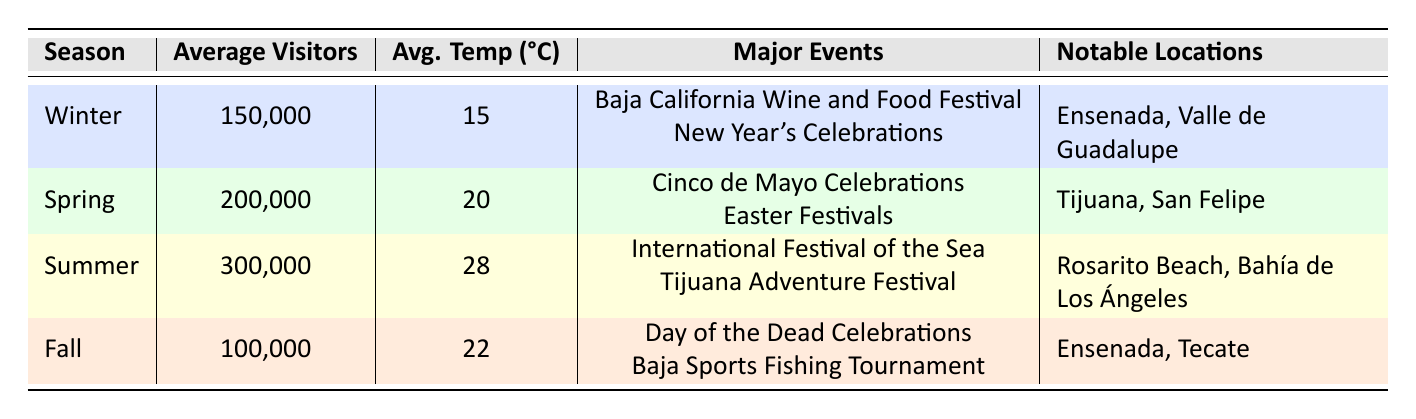What is the average number of visitors during the summer season? From the table, the summer season has 300,000 average visitors listed under the "Average Visitors" column.
Answer: 300,000 Which season has the highest average temperature? By examining the average temperature values in the table, summer has the highest average temperature at 28 degrees Celsius.
Answer: Summer How many major events are celebrated in spring? The spring season lists two major events: "Cinco de Mayo Celebrations" and "Easter Festivals," as shown in the table under the "Major Events" column.
Answer: 2 What is the total number of average visitors across all seasons? To find the total number of average visitors, we need to sum the average visitors from each season: 150,000 (Winter) + 200,000 (Spring) + 300,000 (Summer) + 100,000 (Fall) = 750,000 visitors.
Answer: 750,000 Is Ensenada a notable location in the fall season? The table indicates that Ensenada is listed under the "Notable Locations" for the fall season, confirming that it is indeed a notable location for this season.
Answer: Yes Which season has the least number of average visitors and what is the number? By comparing the average visitors among all seasons, fall has the least number of average visitors at 100,000, as evidenced in the table.
Answer: Fall, 100,000 During which season do visitors experience the highest average temperature and how much is it? The summer season provides the highest average temperature at 28 degrees Celsius, according to the "Avg. Temp" column in the table.
Answer: Summer, 28 degrees Celsius Is there any major event occurring in winter related to food and wine? Yes, the table mentions the "Baja California Wine and Food Festival" as a major event in the winter season, confirming that there is a relevant event.
Answer: Yes What is the difference in average visitors between summer and fall? The average visitors in summer is 300,000 while in fall it is 100,000. The difference is calculated as: 300,000 - 100,000 = 200,000 visitors.
Answer: 200,000 